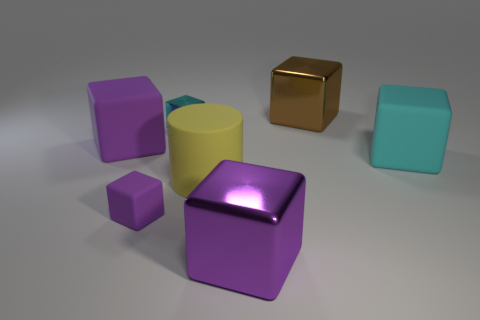What size is the purple matte thing behind the big yellow rubber cylinder that is in front of the big cyan matte cube?
Offer a terse response. Large. What number of tiny matte blocks have the same color as the small metallic thing?
Give a very brief answer. 0. How many big green metallic blocks are there?
Provide a succinct answer. 0. What number of cyan things have the same material as the tiny cyan block?
Make the answer very short. 0. What size is the purple shiny thing that is the same shape as the brown object?
Your response must be concise. Large. What material is the tiny cyan object?
Provide a succinct answer. Metal. There is a big purple thing in front of the large purple thing behind the rubber block that is right of the small purple object; what is its material?
Ensure brevity in your answer.  Metal. Are there any other things that are the same shape as the tiny cyan object?
Give a very brief answer. Yes. The other tiny thing that is the same shape as the cyan metal thing is what color?
Your response must be concise. Purple. Do the small object that is in front of the large yellow cylinder and the large object behind the cyan shiny thing have the same color?
Offer a terse response. No. 